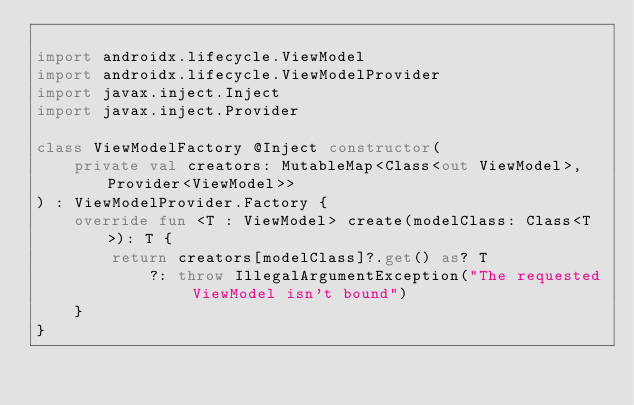Convert code to text. <code><loc_0><loc_0><loc_500><loc_500><_Kotlin_>
import androidx.lifecycle.ViewModel
import androidx.lifecycle.ViewModelProvider
import javax.inject.Inject
import javax.inject.Provider

class ViewModelFactory @Inject constructor(
    private val creators: MutableMap<Class<out ViewModel>, Provider<ViewModel>>
) : ViewModelProvider.Factory {
    override fun <T : ViewModel> create(modelClass: Class<T>): T {
        return creators[modelClass]?.get() as? T
            ?: throw IllegalArgumentException("The requested ViewModel isn't bound")
    }
}
</code> 